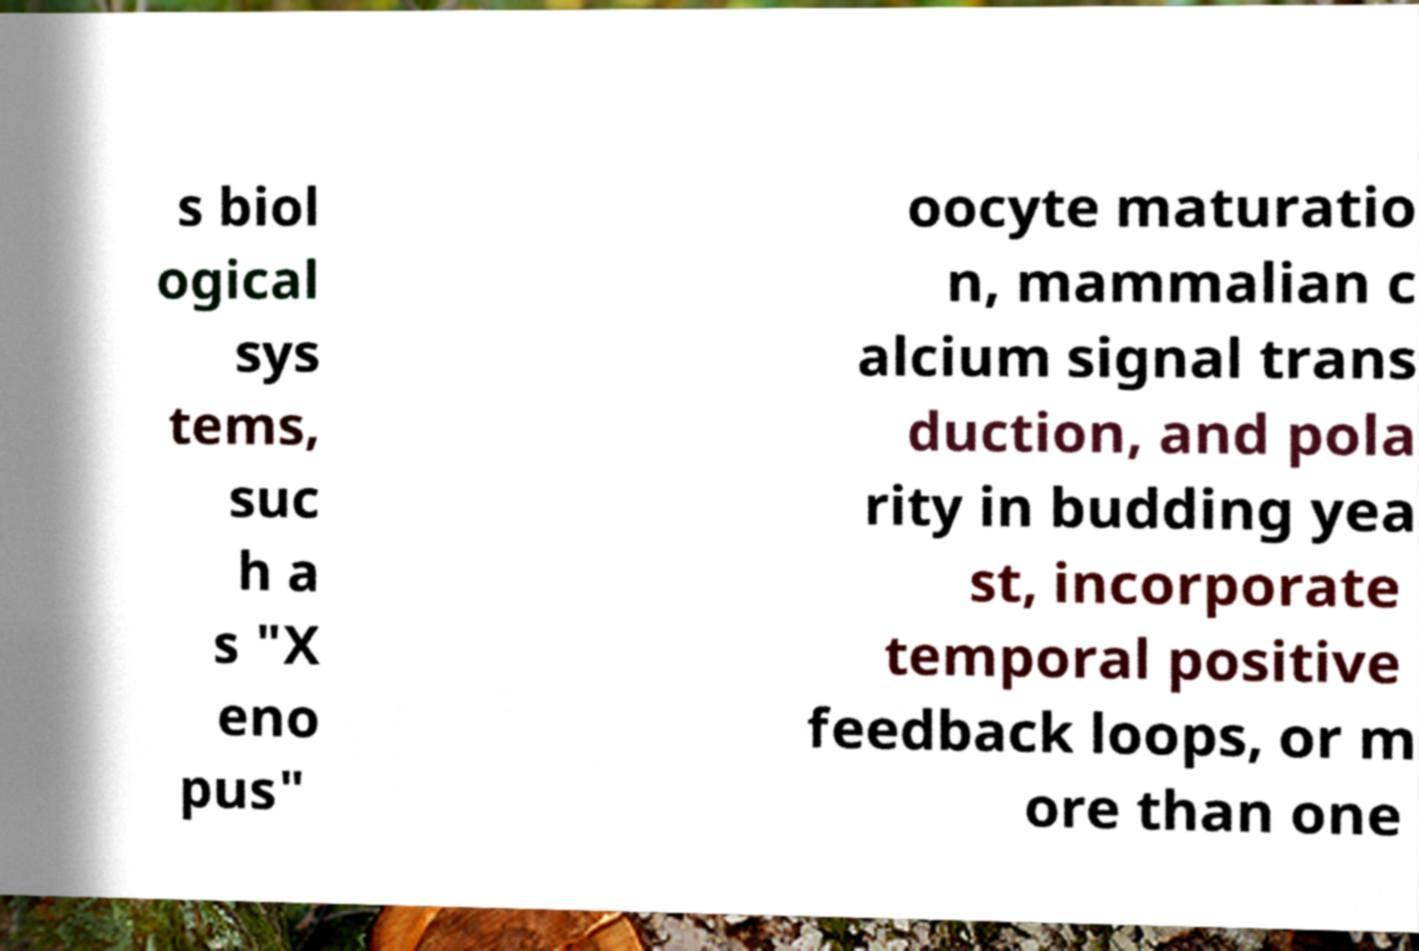Please identify and transcribe the text found in this image. s biol ogical sys tems, suc h a s "X eno pus" oocyte maturatio n, mammalian c alcium signal trans duction, and pola rity in budding yea st, incorporate temporal positive feedback loops, or m ore than one 